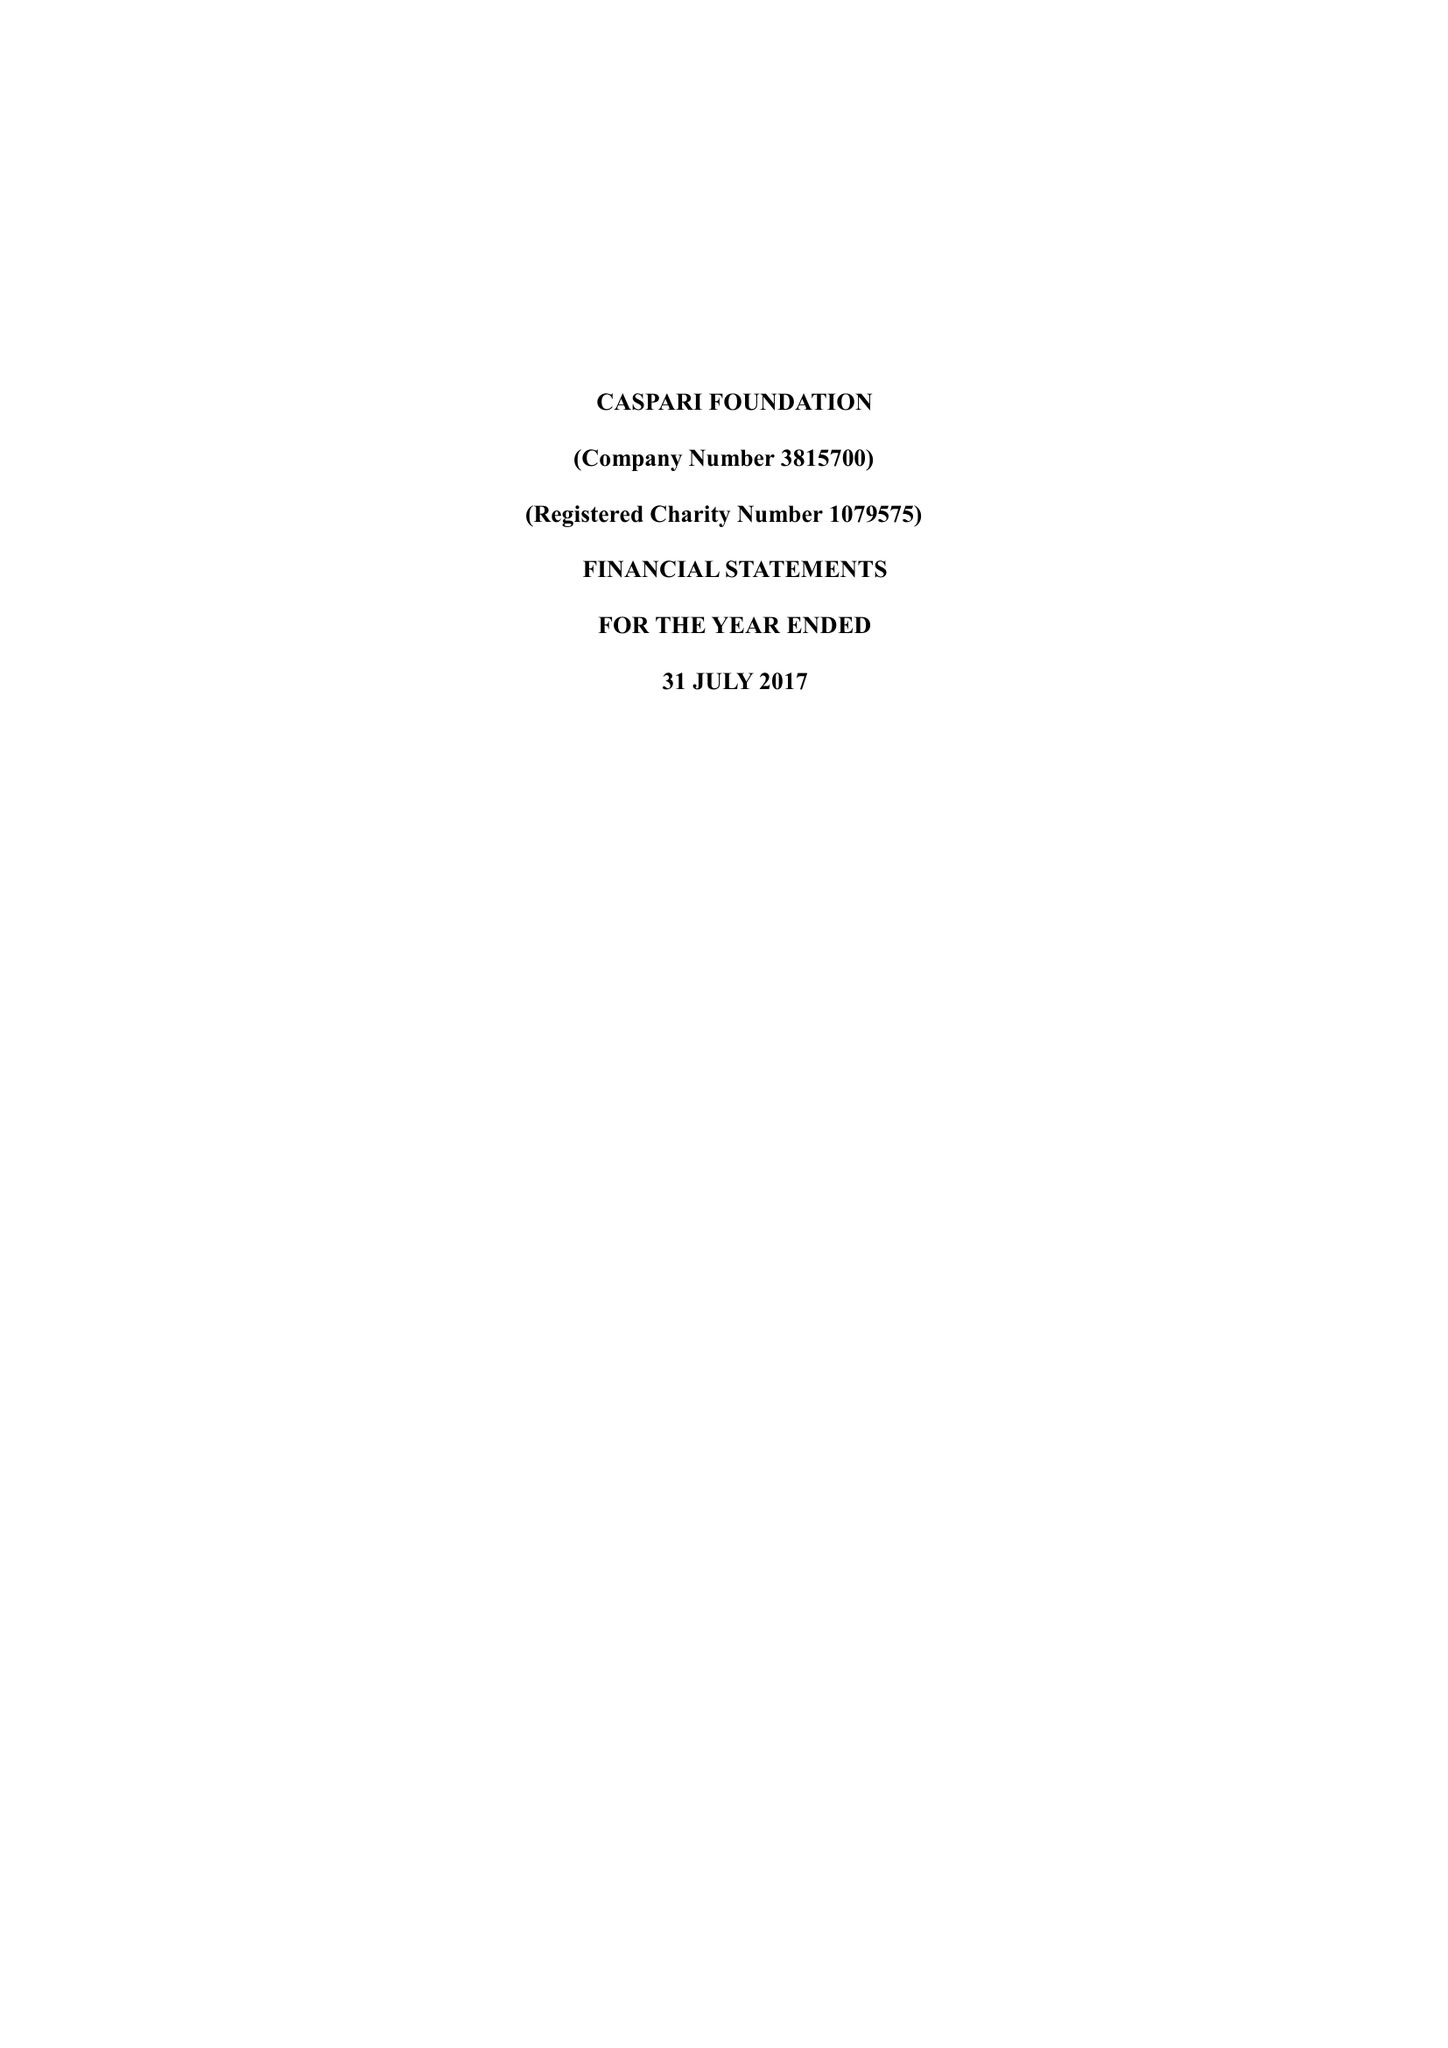What is the value for the income_annually_in_british_pounds?
Answer the question using a single word or phrase. 187868.00 